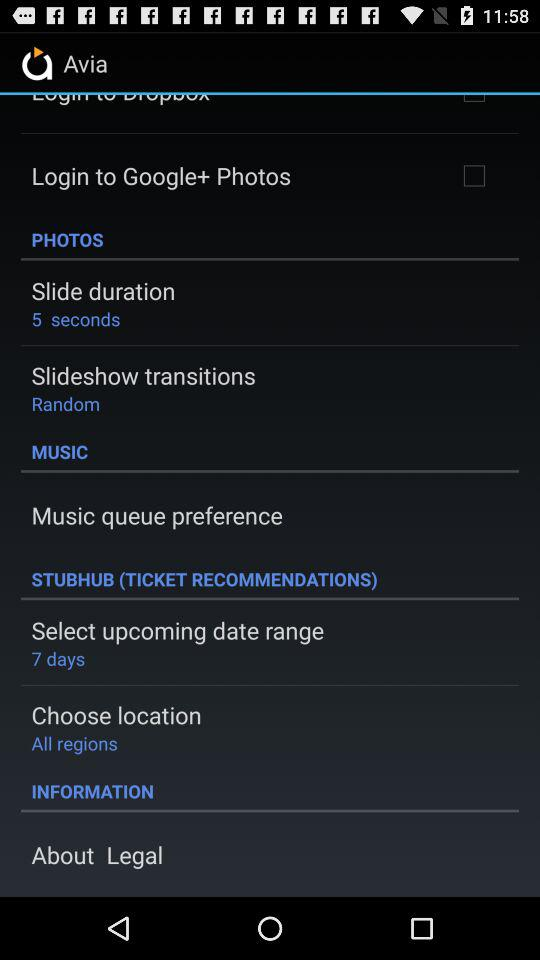What is the setting for "Select upcoming date range"? The setting for "Select upcoming date range" is "7 days". 